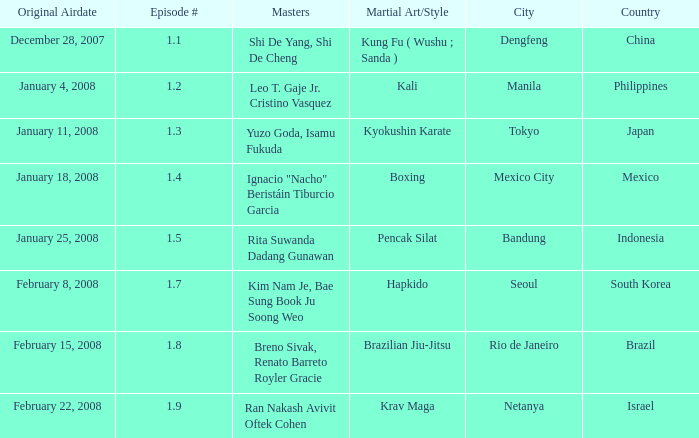Which martial arts style was shown in Rio de Janeiro? Brazilian Jiu-Jitsu. 